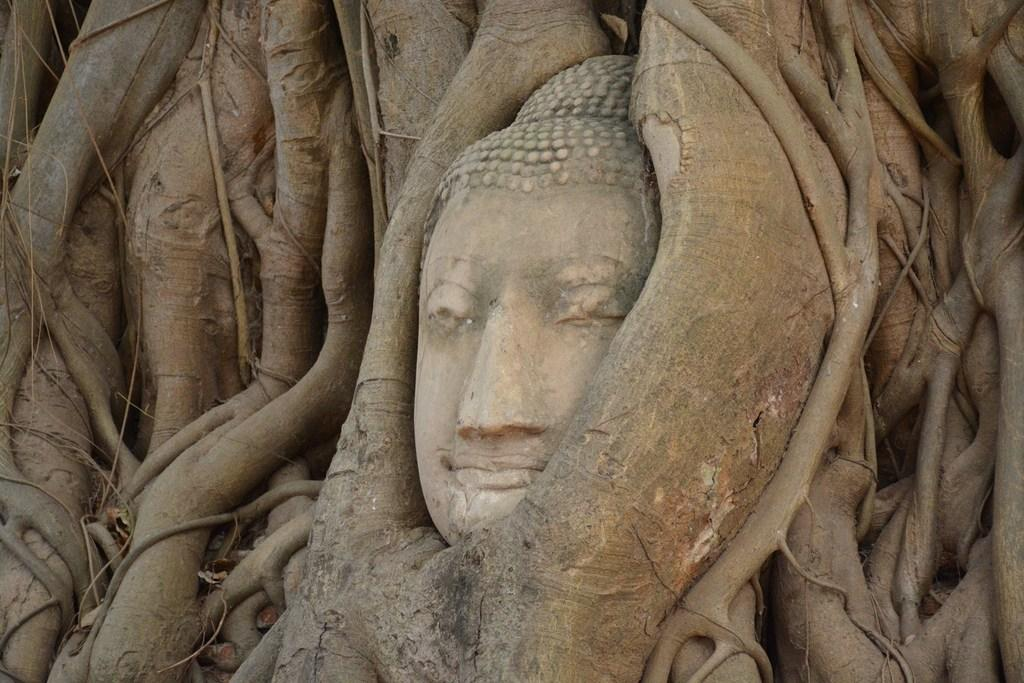What is the main subject of the image? There is a sculpture in the image. What else can be seen in the image besides the sculpture? The trunks of trees are visible in the image. How many servants are standing next to the sculpture in the image? There are no servants present in the image; it only features a sculpture and tree trunks. What type of leg can be seen supporting the sculpture in the image? There is no leg supporting the sculpture in the image; it is a standalone sculpture. 